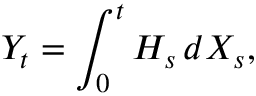Convert formula to latex. <formula><loc_0><loc_0><loc_500><loc_500>Y _ { t } = \int _ { 0 } ^ { t } H _ { s } \, d X _ { s } ,</formula> 